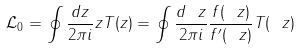<formula> <loc_0><loc_0><loc_500><loc_500>\mathcal { L } _ { 0 } = \oint \frac { d z } { 2 \pi i } z T ( z ) = \oint \frac { d \ z } { 2 \pi i } \frac { f ( \ z ) } { f ^ { \prime } ( \ z ) } T ( \ z )</formula> 